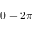<formula> <loc_0><loc_0><loc_500><loc_500>0 - 2 \pi</formula> 